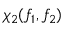<formula> <loc_0><loc_0><loc_500><loc_500>\chi _ { 2 } ( f _ { 1 } , f _ { 2 } )</formula> 